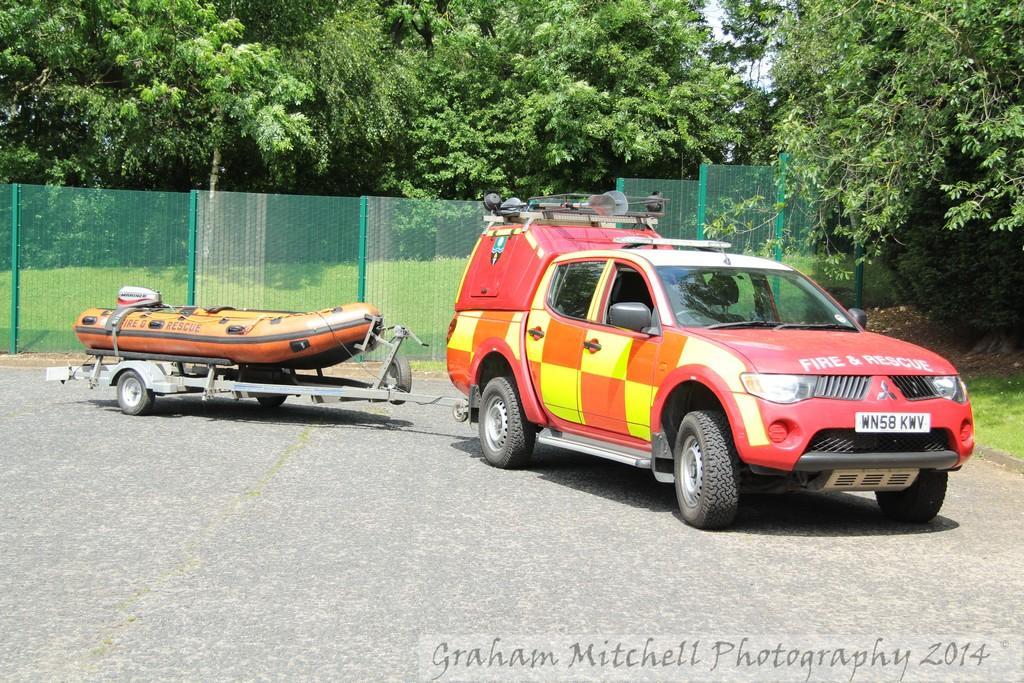Describe this image in one or two sentences. On the bottom right, there is a watermark. On the right side, there is a vehicle on the road. On the left side, there is a boat on a trolley which is connected to this vehicle. In the background, there are trees, a fence and grass on the ground and there is sky. 